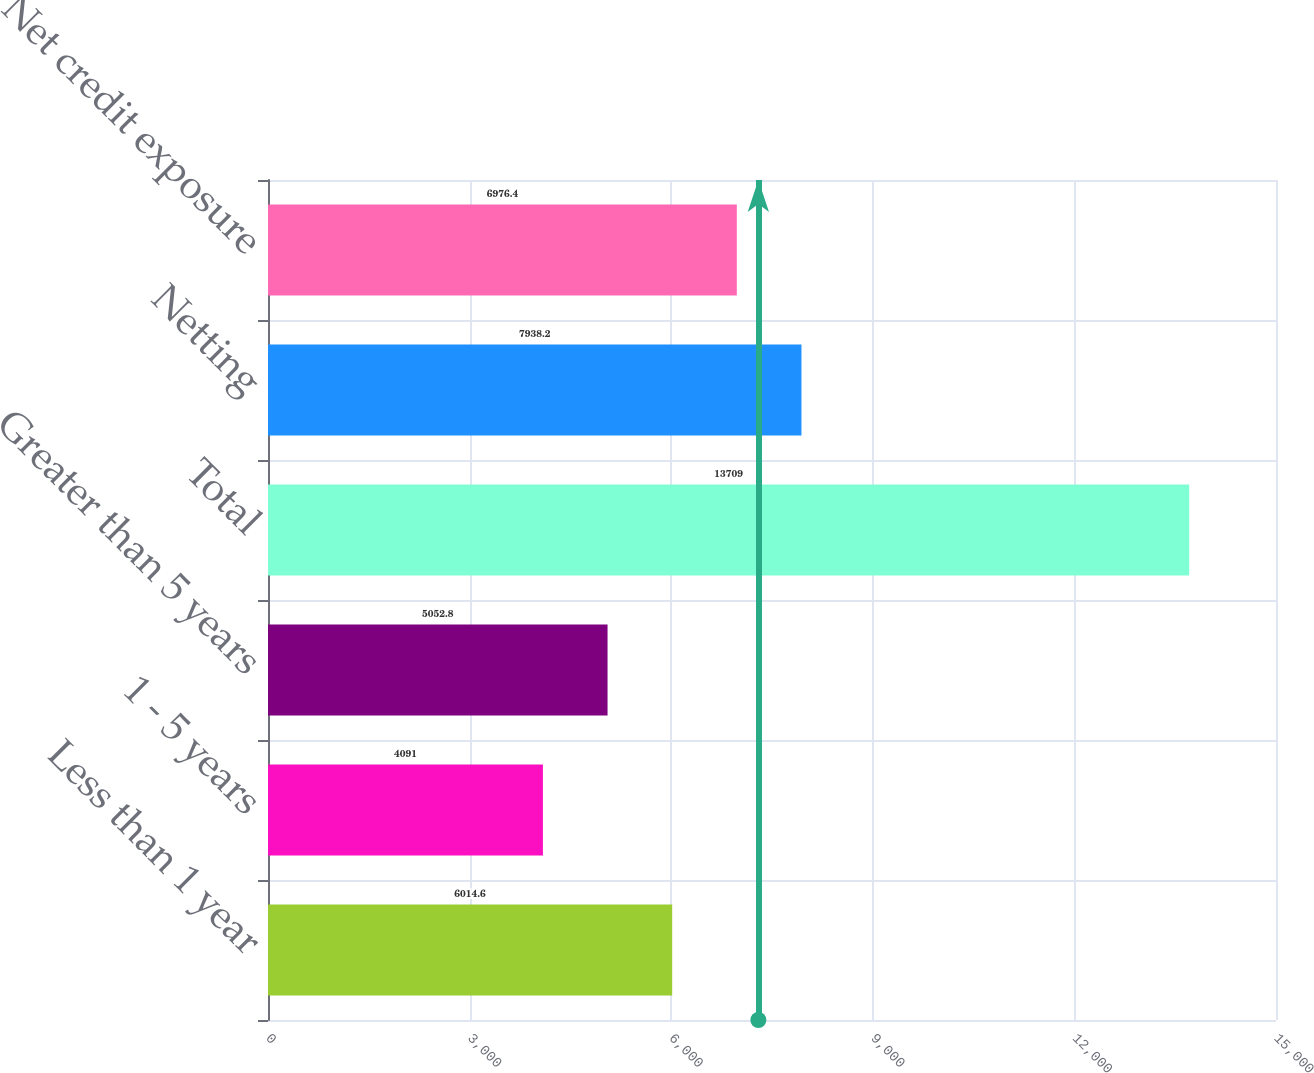Convert chart. <chart><loc_0><loc_0><loc_500><loc_500><bar_chart><fcel>Less than 1 year<fcel>1 - 5 years<fcel>Greater than 5 years<fcel>Total<fcel>Netting<fcel>Net credit exposure<nl><fcel>6014.6<fcel>4091<fcel>5052.8<fcel>13709<fcel>7938.2<fcel>6976.4<nl></chart> 